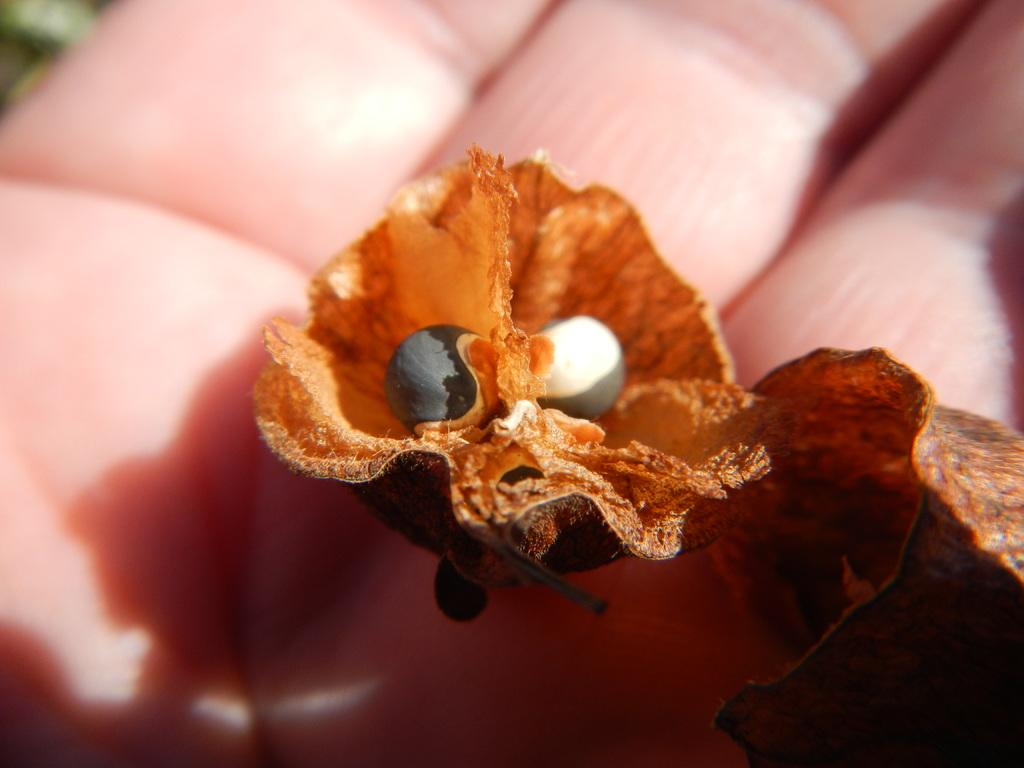What type of living organisms can be seen in the image? There are flowers in the image. Can you describe any other elements in the image? A human hand is visible in the image. What type of skate is being used to drain the value from the flowers in the image? There is no skate or draining activity present in the image; it features flowers and a human hand. 